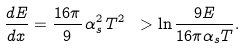<formula> <loc_0><loc_0><loc_500><loc_500>\frac { d E } { d x } = \frac { 1 6 \pi } { 9 } \, \alpha _ { s } ^ { 2 } \, T ^ { 2 } \ > \ln \frac { 9 E } { 1 6 \pi \alpha _ { s } T } .</formula> 